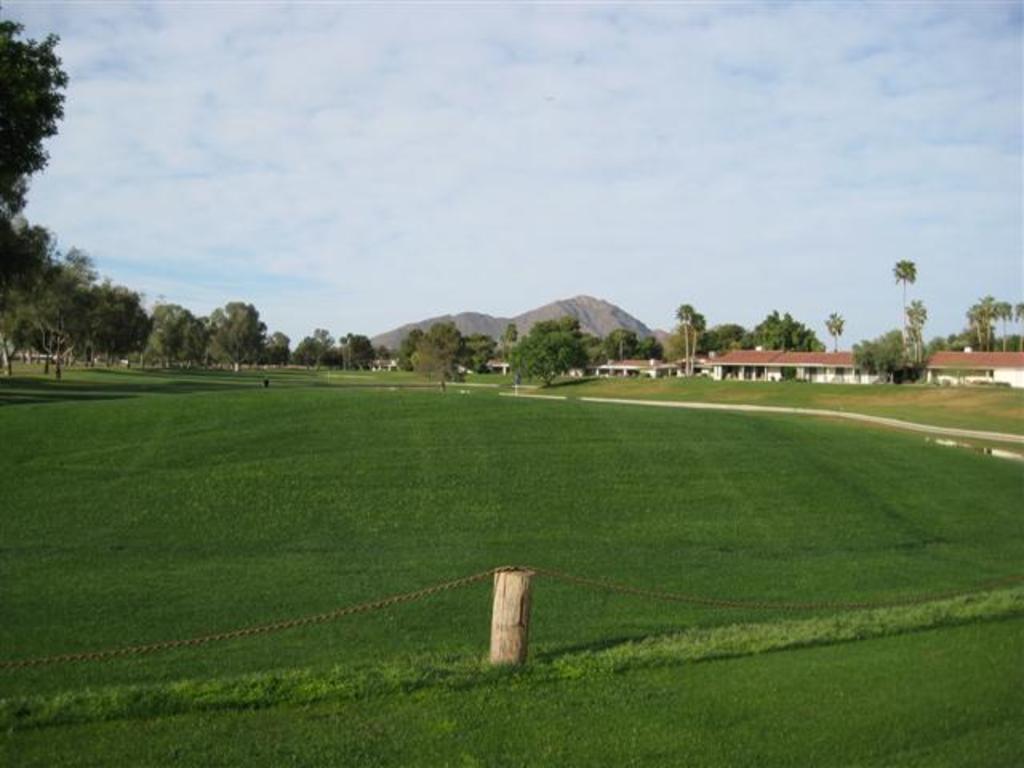How would you summarize this image in a sentence or two? In this picture we can see grass at the bottom, in the background we can see houses, trees and a hill, there is the sky and clouds at the top of the picture, there is wood in the front. 